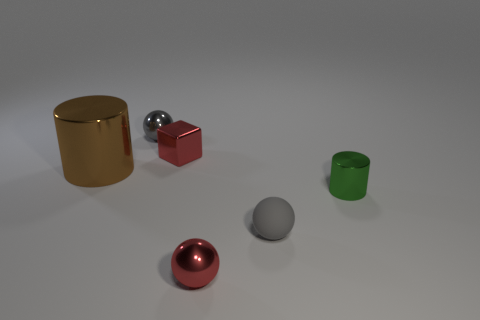Add 2 tiny blue shiny things. How many objects exist? 8 Subtract all small metal spheres. How many spheres are left? 1 Subtract all green cylinders. How many cylinders are left? 1 Add 6 gray spheres. How many gray spheres exist? 8 Subtract 0 cyan blocks. How many objects are left? 6 Subtract all cylinders. How many objects are left? 4 Subtract 1 balls. How many balls are left? 2 Subtract all purple cubes. Subtract all yellow spheres. How many cubes are left? 1 Subtract all green cylinders. How many gray spheres are left? 2 Subtract all cyan objects. Subtract all spheres. How many objects are left? 3 